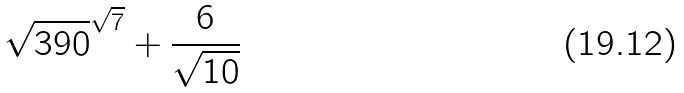Convert formula to latex. <formula><loc_0><loc_0><loc_500><loc_500>\sqrt { 3 9 0 } ^ { \sqrt { 7 } } + \frac { 6 } { \sqrt { 1 0 } }</formula> 